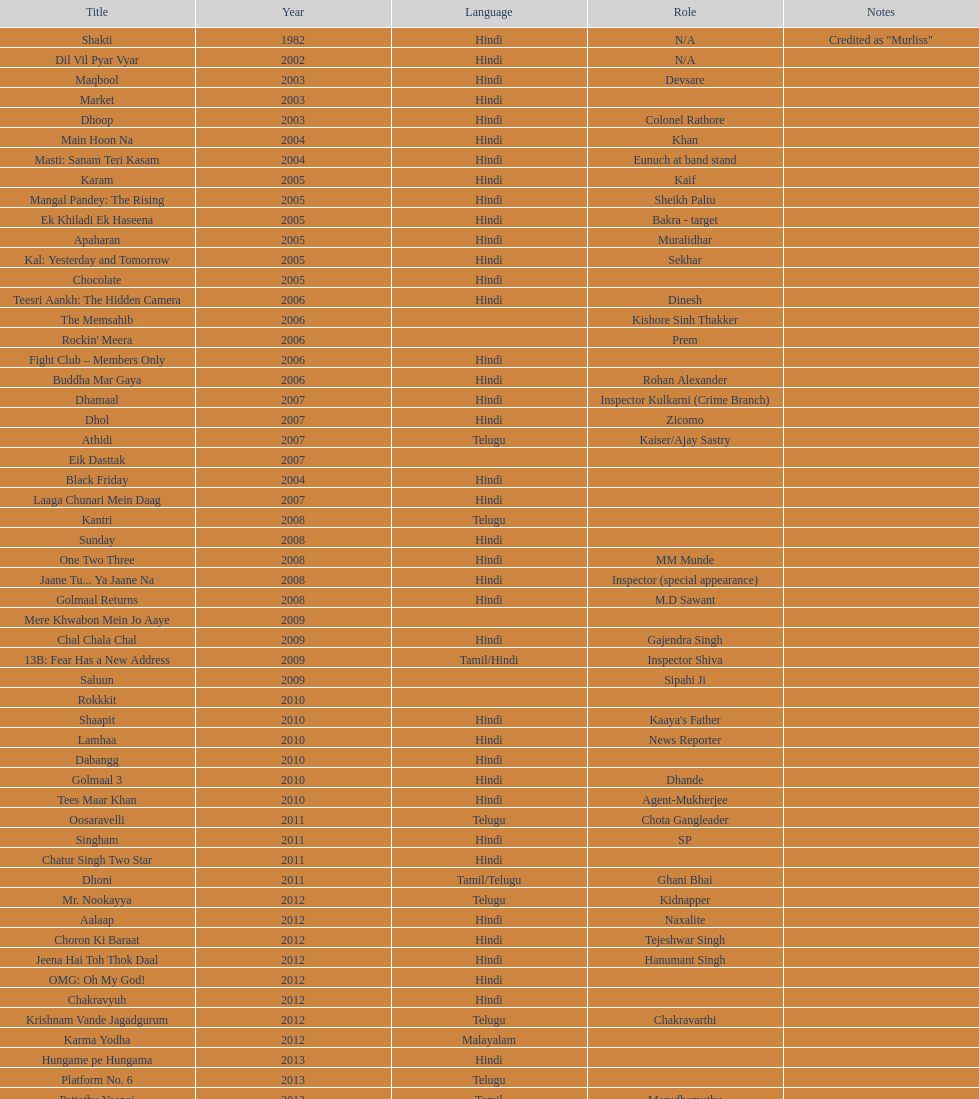What is the total years on the chart 13. 